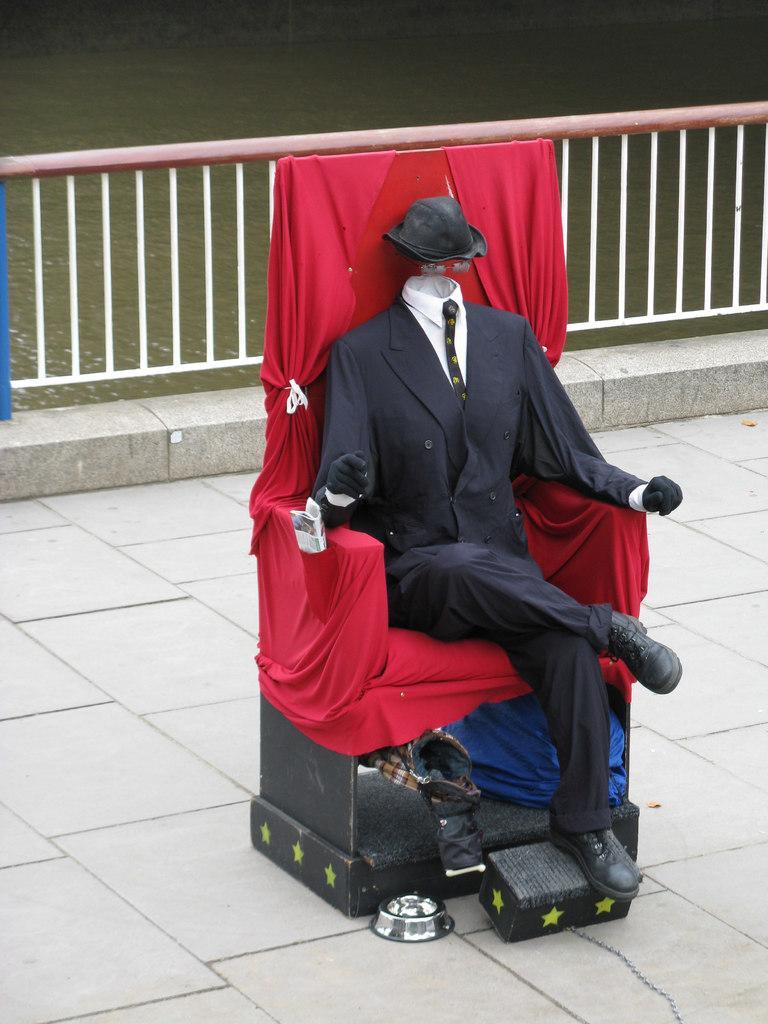Can you describe this image briefly? In this image I can see in the middle there is a mannequin on the chair. There are clothes, at the back side there is the railing, at the top there is water. 